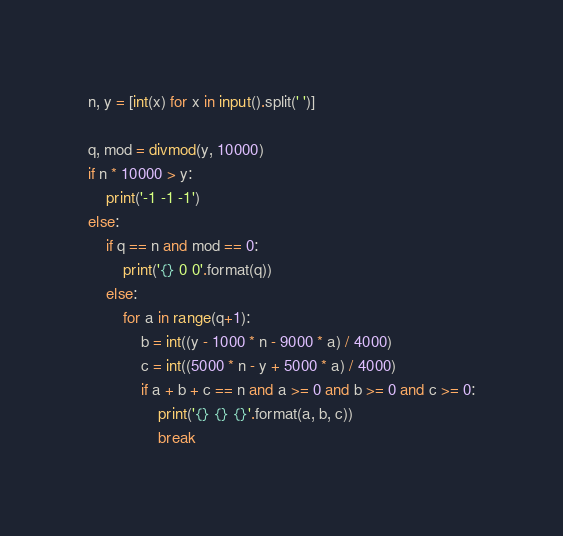Convert code to text. <code><loc_0><loc_0><loc_500><loc_500><_Python_>n, y = [int(x) for x in input().split(' ')]

q, mod = divmod(y, 10000)
if n * 10000 > y:
    print('-1 -1 -1')
else:
	if q == n and mod == 0:
		print('{} 0 0'.format(q))
	else:
		for a in range(q+1):
			b = int((y - 1000 * n - 9000 * a) / 4000)
			c = int((5000 * n - y + 5000 * a) / 4000)
			if a + b + c == n and a >= 0 and b >= 0 and c >= 0:
				print('{} {} {}'.format(a, b, c))
				break
</code> 